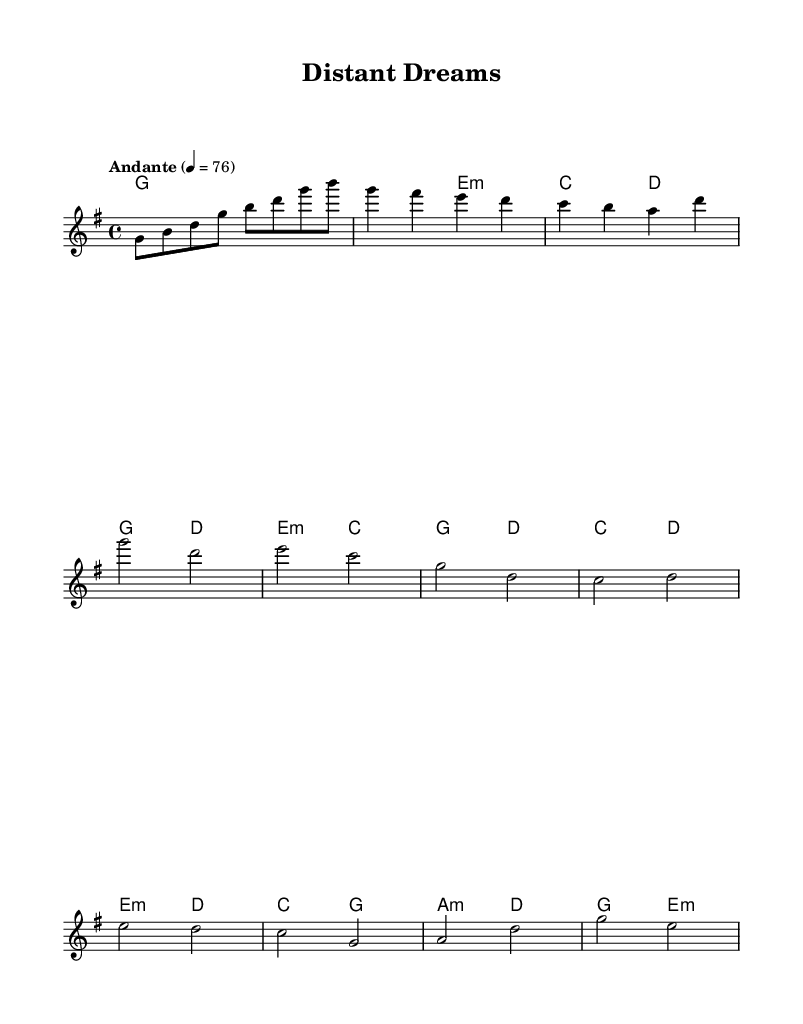What is the key signature of this music? The key signature indicates two sharps, which corresponds to D major or B minor; however, since the context indicates a major tonality, it is G major.
Answer: G major What is the time signature of this music? The time signature is indicated at the beginning of the score and is written as "4/4", which means there are four beats in each measure.
Answer: 4/4 What is the tempo marking in this music? The tempo is marked "Andante," which instructs the performer to play at a moderately slow pace. The metronome marking indicates a speed of 76 beats per minute.
Answer: Andante How many measures are in the intro section? By analyzing the sheet music, the "Intro" section consists of one line, which contains four measures.
Answer: 4 What type of chord appears at the beginning of the piece? The first chord is indicated in the chord names and is labeled as "g1," suggesting a G major chord in its root position, standing alone.
Answer: G major What specific feature in K-Pop ballads is reflected in the melodic structure? K-Pop ballads often incorporate contrasting sections with distinct emotional builds; here, the bridge presents a change in melody and harmony that enhances the ballad's emotional impact.
Answer: Emotional build What is the function of the bridge in this piece? The bridge serves as a contrasting section to the verses and choruses, typically providing a moment of reflection or emotional intensity, demonstrated here by the change in melody and harmonies.
Answer: Contrast 